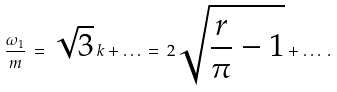Convert formula to latex. <formula><loc_0><loc_0><loc_500><loc_500>\frac { \omega _ { 1 } } { m } \, = \, \sqrt { 3 } \, k + \dots \, = \, 2 \sqrt { \frac { r } { \pi } - 1 } + \dots \, .</formula> 